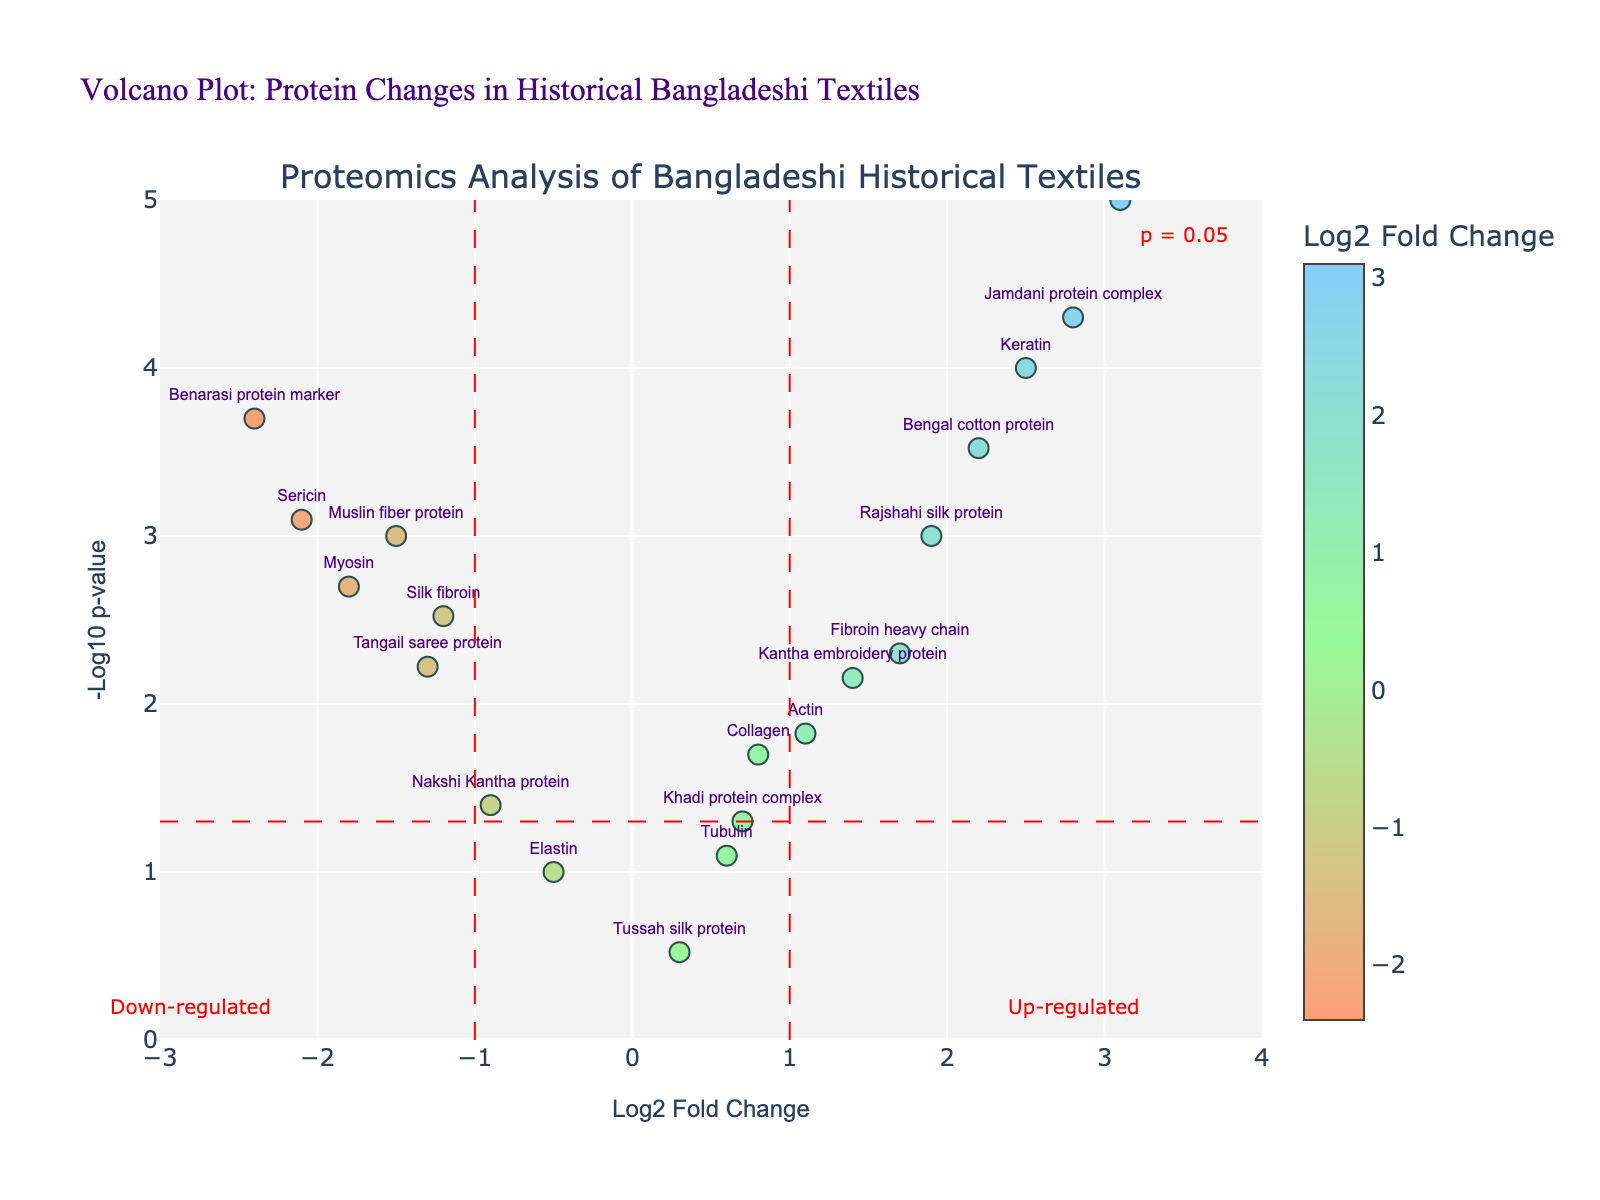What is the title of the plot? The title is displayed at the top of the plot, indicating the subject of the analysis.
Answer: "Volcano Plot: Protein Changes in Historical Bangladeshi Textiles" How many data points are there in the plot? By counting the number of markers (dots) displayed in the plot, we can determine the total number of data points.
Answer: 19 Which protein has the highest log2 fold change? By examining the x-axis for the maximum value, we see that "Dhaka muslin protein" has the highest log2 fold change.
Answer: "Dhaka muslin protein" What is the log2 fold change and p-value of the "Sericin" protein? Locate the "Sericin" label and read off the corresponding log2 fold change (x-axis) and p-value (y-axis inverted). The log2 fold change is -2.1 and the p-value is shown as -log10(p-value), which is approximately 0.0008.
Answer: Log2 fold change: -2.1, p-value: 0.0008 Which proteins are considered significantly up-regulated? Significantly up-regulated proteins would have a log2 fold change greater than 1 and a p-value less than 0.05 (above the horizontal significance line and to the right of the vertical red line at x=1).
Answer: "Keratin", "Fibroin heavy chain", "Jamdani protein complex", "Bengal cotton protein", "Dhaka muslin protein", "Rajshahi silk protein" Which protein has the lowest p-value? The protein with the highest -log10(p) value (y-axis) has the lowest p-value. Observing the y-axis, "Dhaka muslin protein" reaches the highest point.
Answer: "Dhaka muslin protein" Identify the most significantly down-regulated protein. Significantly down-regulated proteins have a log2 fold change less than -1 and a p-value less than 0.05. The lowest log2 fold change value indicates the most significant down-regulation.
Answer: "Benarasi protein marker" What is the log2 fold change range depicted in the plot? The range can be inferred by observing the x-axis limits set in the plot.
Answer: -3 to 4 How does the "Actin" protein compare to the "Myosin" protein in terms of their log2 fold change and p-values? Examine the x and y coordinates of both "Actin" and "Myosin". "Actin" has a positive log2 fold change (1.1) and a lower -log10(p) value, whereas "Myosin" has a negative log2 fold change (-1.8) and a higher -log10(p) value.
Answer: "Actin" is up-regulated, "Myosin" is down-regulated How many proteins have a log2 fold change greater than 2? Count the number of markers to the right of the x=2 line on the plot.
Answer: 3 